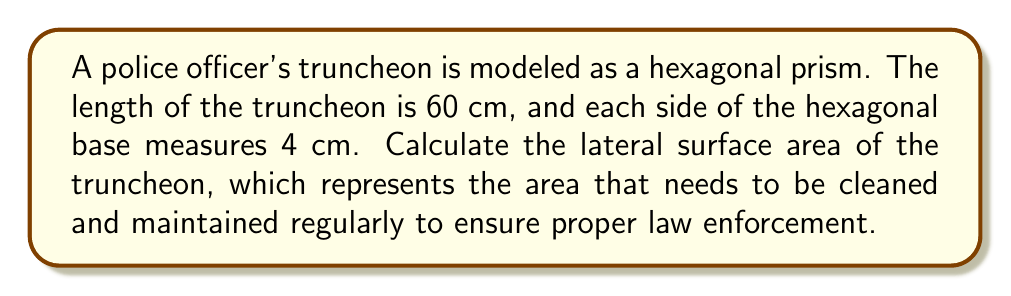Provide a solution to this math problem. To calculate the lateral surface area of a hexagonal prism, we need to follow these steps:

1. Determine the perimeter of the hexagonal base:
   $$P = 6s$$
   where $s$ is the length of each side of the hexagon.
   $$P = 6 \times 4 = 24 \text{ cm}$$

2. Use the formula for the lateral surface area of a prism:
   $$A_{\text{lateral}} = Ph$$
   where $P$ is the perimeter of the base and $h$ is the height (length) of the prism.

3. Substitute the values:
   $$A_{\text{lateral}} = 24 \text{ cm} \times 60 \text{ cm} = 1440 \text{ cm}^2$$

[asy]
import geometry;

size(200);
real s = 1;
real h = 3;
pair A = (0,0), B = (s,0), C = (1.5*s,0.866*s), D = (s,1.732*s), E = (0,1.732*s), F = (-0.5*s,0.866*s);
pair A' = A+(0,h), B' = B+(0,h), C' = C+(0,h), D' = D+(0,h), E' = E+(0,h), F' = F+(0,h);

draw(A--B--C--D--E--F--cycle);
draw(A'--B'--C'--D'--E'--F'--cycle);
draw(A--A', B--B', C--C', D--D', E--E', F--F');

label("4 cm", (A+B)/2, S);
label("60 cm", (A+A')/2, W);
[/asy]

Therefore, the lateral surface area of the truncheon is 1440 square centimeters.
Answer: $$1440 \text{ cm}^2$$ 